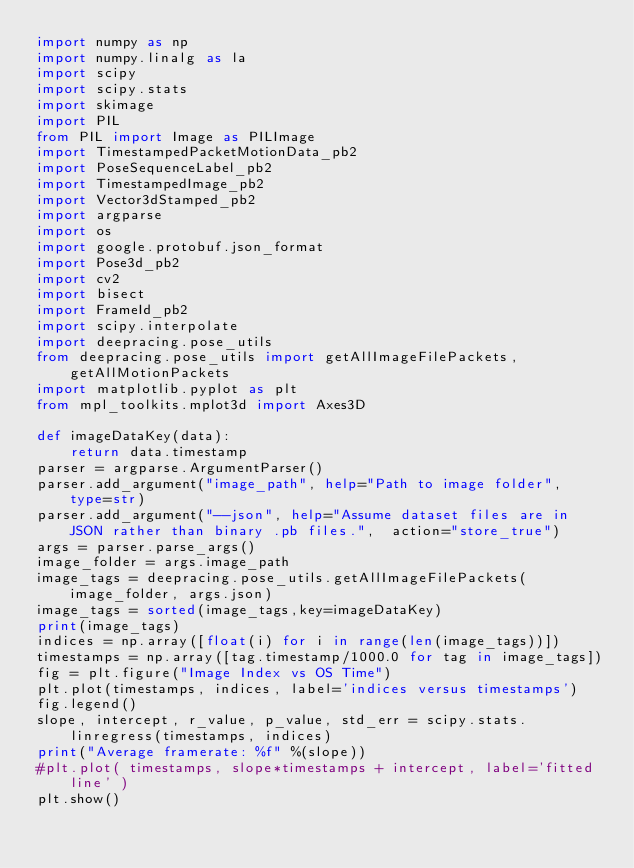<code> <loc_0><loc_0><loc_500><loc_500><_Python_>import numpy as np
import numpy.linalg as la
import scipy
import scipy.stats
import skimage
import PIL
from PIL import Image as PILImage
import TimestampedPacketMotionData_pb2
import PoseSequenceLabel_pb2
import TimestampedImage_pb2
import Vector3dStamped_pb2
import argparse
import os
import google.protobuf.json_format
import Pose3d_pb2
import cv2
import bisect
import FrameId_pb2
import scipy.interpolate
import deepracing.pose_utils
from deepracing.pose_utils import getAllImageFilePackets, getAllMotionPackets
import matplotlib.pyplot as plt
from mpl_toolkits.mplot3d import Axes3D

def imageDataKey(data):
    return data.timestamp
parser = argparse.ArgumentParser()
parser.add_argument("image_path", help="Path to image folder",  type=str)
parser.add_argument("--json", help="Assume dataset files are in JSON rather than binary .pb files.",  action="store_true")
args = parser.parse_args()
image_folder = args.image_path
image_tags = deepracing.pose_utils.getAllImageFilePackets(image_folder, args.json)
image_tags = sorted(image_tags,key=imageDataKey)
print(image_tags)
indices = np.array([float(i) for i in range(len(image_tags))])
timestamps = np.array([tag.timestamp/1000.0 for tag in image_tags])
fig = plt.figure("Image Index vs OS Time")
plt.plot(timestamps, indices, label='indices versus timestamps')
fig.legend()
slope, intercept, r_value, p_value, std_err = scipy.stats.linregress(timestamps, indices)
print("Average framerate: %f" %(slope))
#plt.plot( timestamps, slope*timestamps + intercept, label='fitted line' )
plt.show()

</code> 